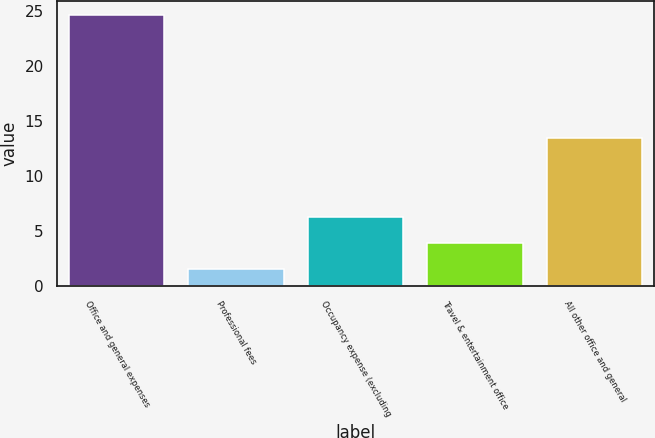Convert chart to OTSL. <chart><loc_0><loc_0><loc_500><loc_500><bar_chart><fcel>Office and general expenses<fcel>Professional fees<fcel>Occupancy expense (excluding<fcel>Travel & entertainment office<fcel>All other office and general<nl><fcel>24.7<fcel>1.6<fcel>6.3<fcel>3.91<fcel>13.5<nl></chart> 